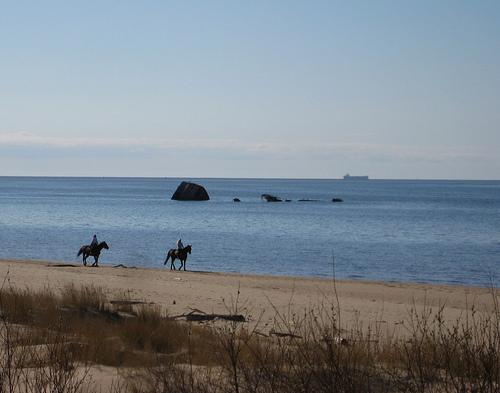Which actor has the training to do what these people are doing?
Indicate the correct response and explain using: 'Answer: answer
Rationale: rationale.'
Options: Russell crowe, kevin james, gabourey sidibe, jacob tremblay. Answer: russell crowe.
Rationale: The people are clearly riding horses and the actor in answer a claims to know this skill based on an internet search. 